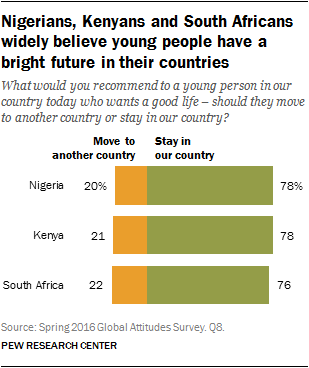Specify some key components in this picture. The green bar represents staying in our country. The ratio between choosing to move to another country versus staying in Kenya is 0.26923... 